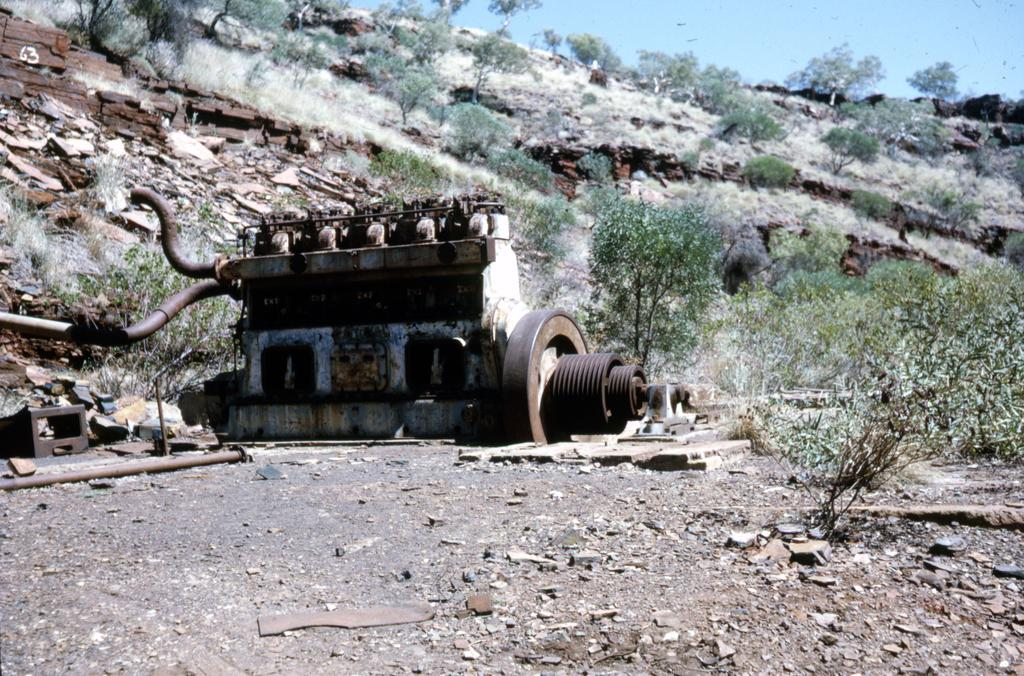What is the main subject in the image? There is a machine in the image. What can be seen on the ground in front of the machine? There are objects on the path in the image. What type of natural scenery is visible in the background? There are trees in the background of the image. What is the color of the sky in the image? The sky is blue in color. How many chickens are present in the image? There are no chickens present in the image. What type of dust can be seen on the machine in the image? There is no dust visible on the machine in the image. 